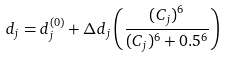Convert formula to latex. <formula><loc_0><loc_0><loc_500><loc_500>d _ { j } = d _ { j } ^ { ( 0 ) } + \Delta d _ { j } \left ( \frac { ( C _ { j } ) ^ { 6 } } { ( C _ { j } ) ^ { 6 } + 0 . 5 ^ { 6 } } \right )</formula> 